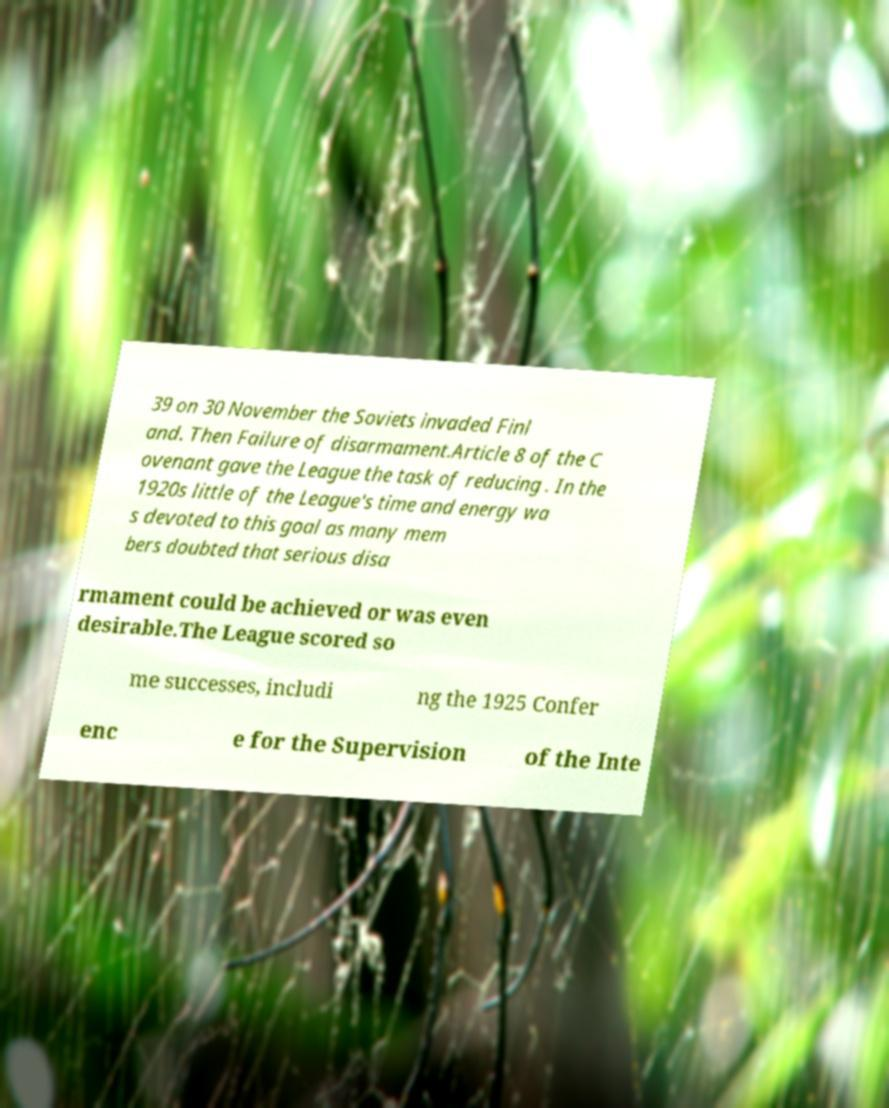There's text embedded in this image that I need extracted. Can you transcribe it verbatim? 39 on 30 November the Soviets invaded Finl and. Then Failure of disarmament.Article 8 of the C ovenant gave the League the task of reducing . In the 1920s little of the League's time and energy wa s devoted to this goal as many mem bers doubted that serious disa rmament could be achieved or was even desirable.The League scored so me successes, includi ng the 1925 Confer enc e for the Supervision of the Inte 